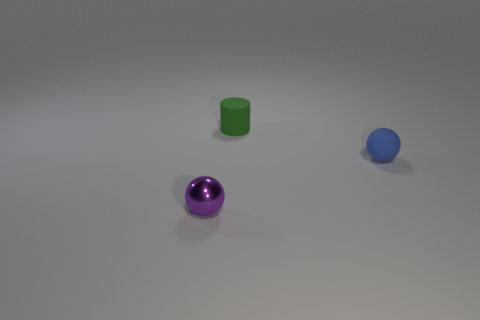How many objects are either small objects behind the small purple thing or purple metal things?
Offer a very short reply. 3. There is a ball that is right of the tiny metal thing; how big is it?
Your response must be concise. Small. There is a green matte object; is its size the same as the sphere behind the small purple object?
Your answer should be compact. Yes. What is the color of the tiny thing that is in front of the sphere that is behind the tiny purple metal ball?
Give a very brief answer. Purple. How big is the shiny object?
Give a very brief answer. Small. Are there more rubber balls left of the small blue matte object than tiny metal objects left of the rubber cylinder?
Provide a succinct answer. No. There is a object that is in front of the small blue sphere; how many tiny things are right of it?
Offer a terse response. 2. Does the matte thing behind the blue matte thing have the same shape as the small purple shiny object?
Ensure brevity in your answer.  No. There is a small blue thing that is the same shape as the purple metallic thing; what is it made of?
Ensure brevity in your answer.  Rubber. What number of red metal cylinders are the same size as the blue rubber object?
Provide a short and direct response. 0. 